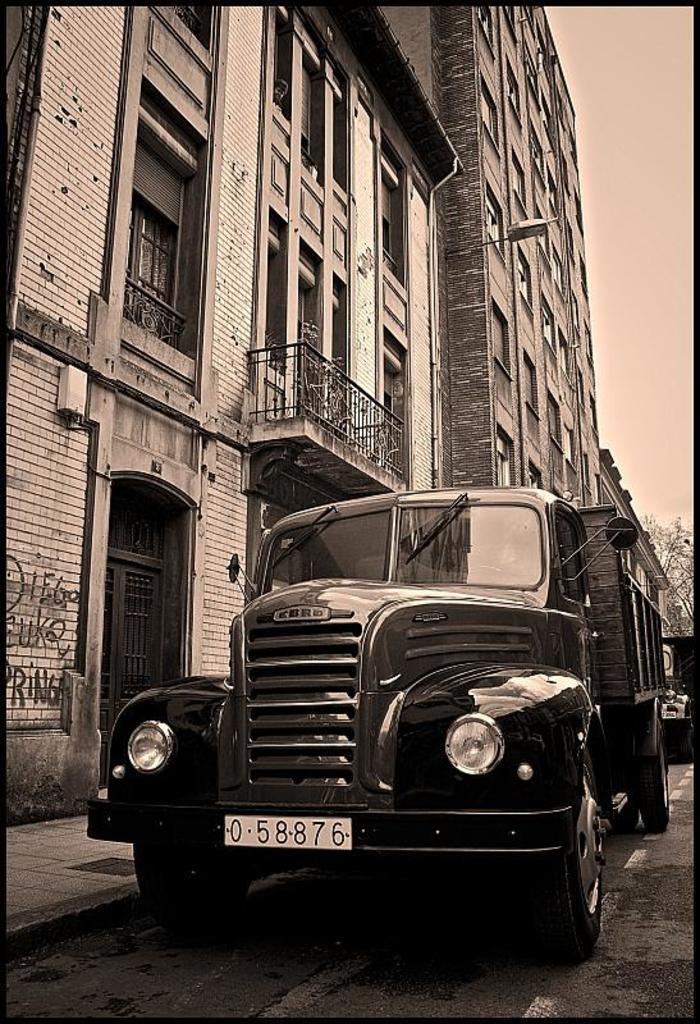What is the main subject of the image? There is a vehicle on the road in the image. What can be seen near the vehicle? There is a building with railing and windows near the vehicle. What type of natural elements are visible in the background of the image? Trees are visible in the background of the image. What part of the natural environment is visible in the image? The sky is visible in the background of the image. Where is the worm located in the image? There is no worm present in the image. What type of store can be seen near the vehicle? There is no store visible in the image; only a building with railing and windows is present. 